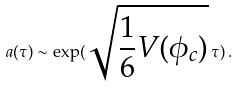<formula> <loc_0><loc_0><loc_500><loc_500>a ( \tau ) \sim \exp ( \sqrt { \frac { 1 } { 6 } V ( \phi _ { c } ) } \, \tau ) \, .</formula> 